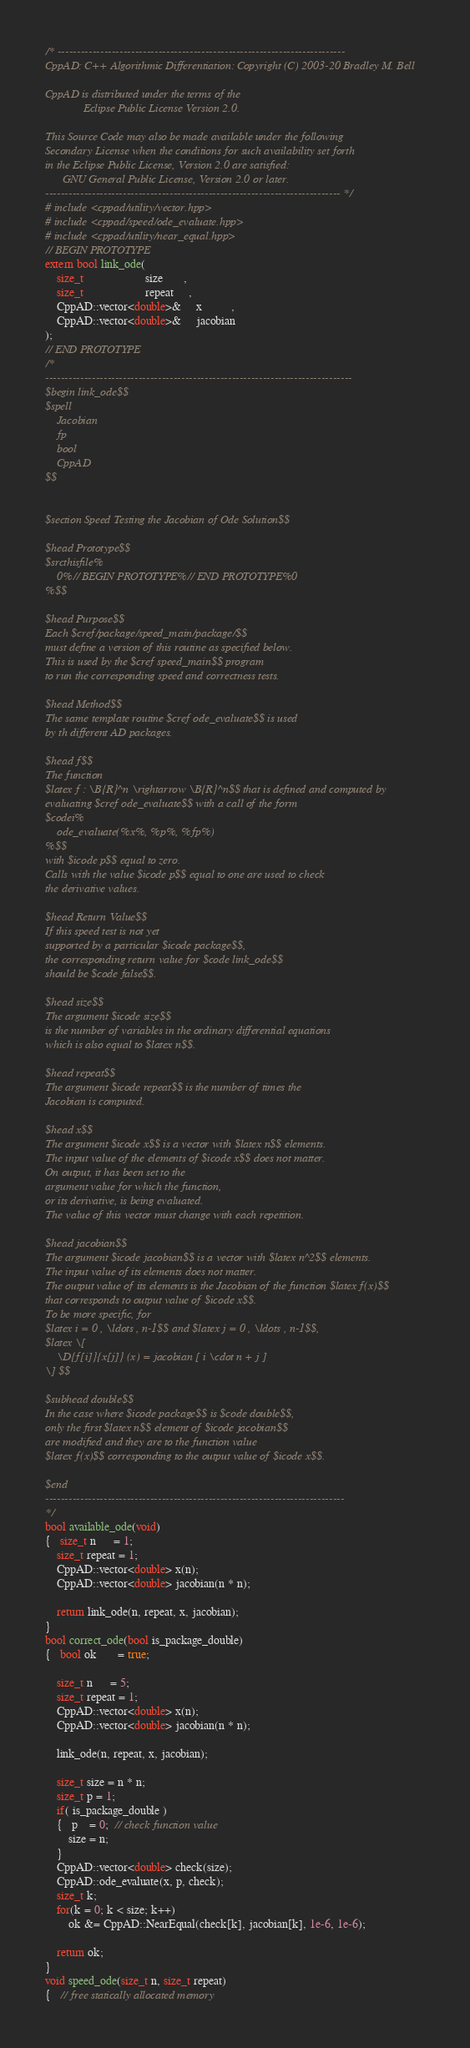<code> <loc_0><loc_0><loc_500><loc_500><_C++_>/* --------------------------------------------------------------------------
CppAD: C++ Algorithmic Differentiation: Copyright (C) 2003-20 Bradley M. Bell

CppAD is distributed under the terms of the
             Eclipse Public License Version 2.0.

This Source Code may also be made available under the following
Secondary License when the conditions for such availability set forth
in the Eclipse Public License, Version 2.0 are satisfied:
      GNU General Public License, Version 2.0 or later.
---------------------------------------------------------------------------- */
# include <cppad/utility/vector.hpp>
# include <cppad/speed/ode_evaluate.hpp>
# include <cppad/utility/near_equal.hpp>
// BEGIN PROTOTYPE
extern bool link_ode(
    size_t                     size       ,
    size_t                     repeat     ,
    CppAD::vector<double>&     x          ,
    CppAD::vector<double>&     jacobian
);
// END PROTOTYPE
/*
-------------------------------------------------------------------------------
$begin link_ode$$
$spell
    Jacobian
    fp
    bool
    CppAD
$$


$section Speed Testing the Jacobian of Ode Solution$$

$head Prototype$$
$srcthisfile%
    0%// BEGIN PROTOTYPE%// END PROTOTYPE%0
%$$

$head Purpose$$
Each $cref/package/speed_main/package/$$
must define a version of this routine as specified below.
This is used by the $cref speed_main$$ program
to run the corresponding speed and correctness tests.

$head Method$$
The same template routine $cref ode_evaluate$$ is used
by th different AD packages.

$head f$$
The function
$latex f : \B{R}^n \rightarrow \B{R}^n$$ that is defined and computed by
evaluating $cref ode_evaluate$$ with a call of the form
$codei%
    ode_evaluate(%x%, %p%, %fp%)
%$$
with $icode p$$ equal to zero.
Calls with the value $icode p$$ equal to one are used to check
the derivative values.

$head Return Value$$
If this speed test is not yet
supported by a particular $icode package$$,
the corresponding return value for $code link_ode$$
should be $code false$$.

$head size$$
The argument $icode size$$
is the number of variables in the ordinary differential equations
which is also equal to $latex n$$.

$head repeat$$
The argument $icode repeat$$ is the number of times the
Jacobian is computed.

$head x$$
The argument $icode x$$ is a vector with $latex n$$ elements.
The input value of the elements of $icode x$$ does not matter.
On output, it has been set to the
argument value for which the function,
or its derivative, is being evaluated.
The value of this vector must change with each repetition.

$head jacobian$$
The argument $icode jacobian$$ is a vector with $latex n^2$$ elements.
The input value of its elements does not matter.
The output value of its elements is the Jacobian of the function $latex f(x)$$
that corresponds to output value of $icode x$$.
To be more specific, for
$latex i = 0 , \ldots , n-1$$ and $latex j = 0 , \ldots , n-1$$,
$latex \[
    \D{f[i]}{x[j]} (x) = jacobian [ i \cdot n + j ]
\] $$

$subhead double$$
In the case where $icode package$$ is $code double$$,
only the first $latex n$$ element of $icode jacobian$$
are modified and they are to the function value
$latex f(x)$$ corresponding to the output value of $icode x$$.

$end
-----------------------------------------------------------------------------
*/
bool available_ode(void)
{   size_t n      = 1;
    size_t repeat = 1;
    CppAD::vector<double> x(n);
    CppAD::vector<double> jacobian(n * n);

    return link_ode(n, repeat, x, jacobian);
}
bool correct_ode(bool is_package_double)
{   bool ok       = true;

    size_t n      = 5;
    size_t repeat = 1;
    CppAD::vector<double> x(n);
    CppAD::vector<double> jacobian(n * n);

    link_ode(n, repeat, x, jacobian);

    size_t size = n * n;
    size_t p = 1;
    if( is_package_double )
    {   p    = 0;  // check function value
        size = n;
    }
    CppAD::vector<double> check(size);
    CppAD::ode_evaluate(x, p, check);
    size_t k;
    for(k = 0; k < size; k++)
        ok &= CppAD::NearEqual(check[k], jacobian[k], 1e-6, 1e-6);

    return ok;
}
void speed_ode(size_t n, size_t repeat)
{   // free statically allocated memory</code> 